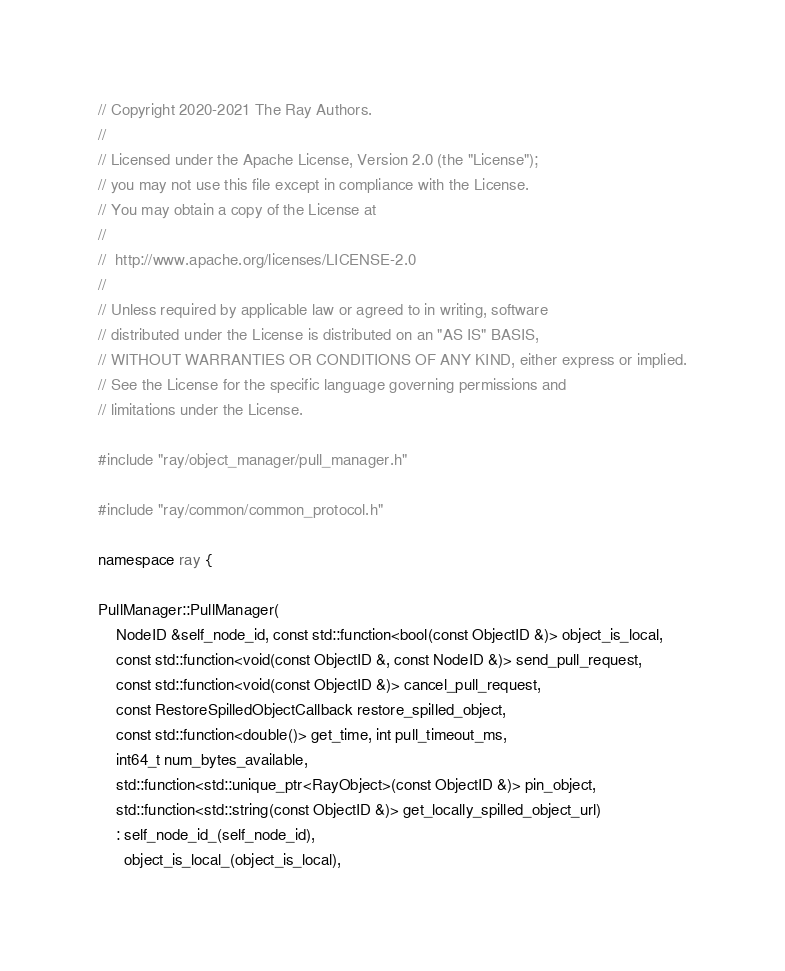<code> <loc_0><loc_0><loc_500><loc_500><_C++_>// Copyright 2020-2021 The Ray Authors.
//
// Licensed under the Apache License, Version 2.0 (the "License");
// you may not use this file except in compliance with the License.
// You may obtain a copy of the License at
//
//  http://www.apache.org/licenses/LICENSE-2.0
//
// Unless required by applicable law or agreed to in writing, software
// distributed under the License is distributed on an "AS IS" BASIS,
// WITHOUT WARRANTIES OR CONDITIONS OF ANY KIND, either express or implied.
// See the License for the specific language governing permissions and
// limitations under the License.

#include "ray/object_manager/pull_manager.h"

#include "ray/common/common_protocol.h"

namespace ray {

PullManager::PullManager(
    NodeID &self_node_id, const std::function<bool(const ObjectID &)> object_is_local,
    const std::function<void(const ObjectID &, const NodeID &)> send_pull_request,
    const std::function<void(const ObjectID &)> cancel_pull_request,
    const RestoreSpilledObjectCallback restore_spilled_object,
    const std::function<double()> get_time, int pull_timeout_ms,
    int64_t num_bytes_available,
    std::function<std::unique_ptr<RayObject>(const ObjectID &)> pin_object,
    std::function<std::string(const ObjectID &)> get_locally_spilled_object_url)
    : self_node_id_(self_node_id),
      object_is_local_(object_is_local),</code> 